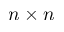<formula> <loc_0><loc_0><loc_500><loc_500>n \times n</formula> 